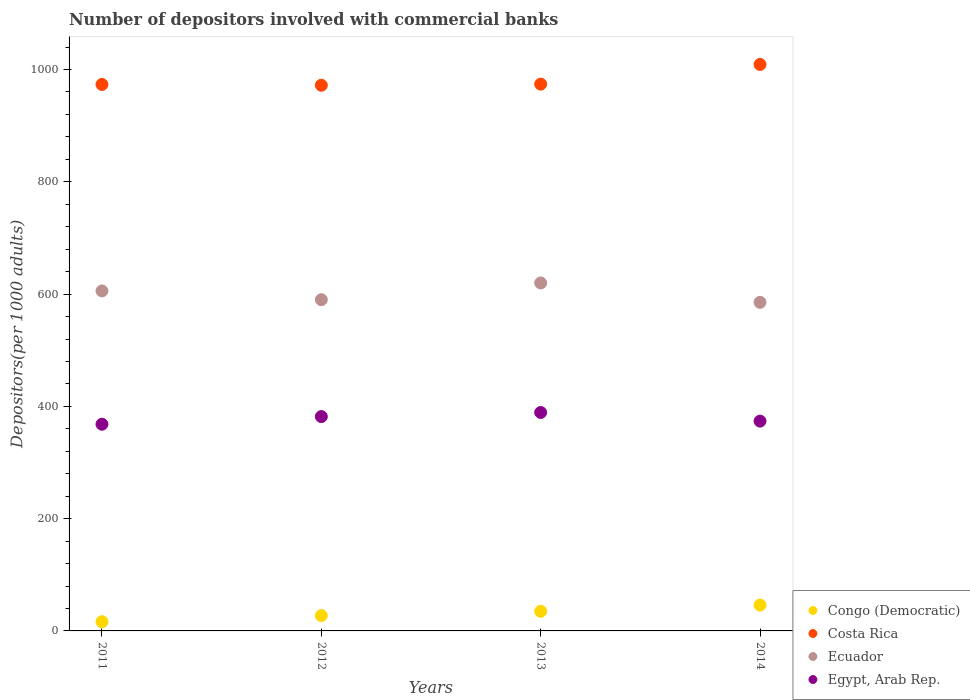Is the number of dotlines equal to the number of legend labels?
Offer a very short reply. Yes. What is the number of depositors involved with commercial banks in Costa Rica in 2012?
Make the answer very short. 972. Across all years, what is the maximum number of depositors involved with commercial banks in Congo (Democratic)?
Offer a terse response. 46.03. Across all years, what is the minimum number of depositors involved with commercial banks in Costa Rica?
Keep it short and to the point. 972. In which year was the number of depositors involved with commercial banks in Congo (Democratic) maximum?
Keep it short and to the point. 2014. What is the total number of depositors involved with commercial banks in Congo (Democratic) in the graph?
Your answer should be very brief. 124.75. What is the difference between the number of depositors involved with commercial banks in Congo (Democratic) in 2012 and that in 2013?
Provide a succinct answer. -7.59. What is the difference between the number of depositors involved with commercial banks in Costa Rica in 2011 and the number of depositors involved with commercial banks in Congo (Democratic) in 2012?
Offer a very short reply. 946.05. What is the average number of depositors involved with commercial banks in Congo (Democratic) per year?
Make the answer very short. 31.19. In the year 2013, what is the difference between the number of depositors involved with commercial banks in Congo (Democratic) and number of depositors involved with commercial banks in Egypt, Arab Rep.?
Provide a short and direct response. -354.15. In how many years, is the number of depositors involved with commercial banks in Egypt, Arab Rep. greater than 960?
Your response must be concise. 0. What is the ratio of the number of depositors involved with commercial banks in Congo (Democratic) in 2012 to that in 2014?
Provide a short and direct response. 0.59. Is the number of depositors involved with commercial banks in Ecuador in 2013 less than that in 2014?
Provide a short and direct response. No. Is the difference between the number of depositors involved with commercial banks in Congo (Democratic) in 2013 and 2014 greater than the difference between the number of depositors involved with commercial banks in Egypt, Arab Rep. in 2013 and 2014?
Your response must be concise. No. What is the difference between the highest and the second highest number of depositors involved with commercial banks in Congo (Democratic)?
Your answer should be very brief. 11.08. What is the difference between the highest and the lowest number of depositors involved with commercial banks in Ecuador?
Offer a very short reply. 34.52. Is the sum of the number of depositors involved with commercial banks in Egypt, Arab Rep. in 2013 and 2014 greater than the maximum number of depositors involved with commercial banks in Congo (Democratic) across all years?
Your answer should be very brief. Yes. Is it the case that in every year, the sum of the number of depositors involved with commercial banks in Ecuador and number of depositors involved with commercial banks in Congo (Democratic)  is greater than the number of depositors involved with commercial banks in Costa Rica?
Ensure brevity in your answer.  No. Is the number of depositors involved with commercial banks in Congo (Democratic) strictly greater than the number of depositors involved with commercial banks in Costa Rica over the years?
Provide a succinct answer. No. How many years are there in the graph?
Make the answer very short. 4. Are the values on the major ticks of Y-axis written in scientific E-notation?
Offer a terse response. No. Does the graph contain any zero values?
Your response must be concise. No. What is the title of the graph?
Your answer should be compact. Number of depositors involved with commercial banks. Does "Cameroon" appear as one of the legend labels in the graph?
Keep it short and to the point. No. What is the label or title of the X-axis?
Make the answer very short. Years. What is the label or title of the Y-axis?
Ensure brevity in your answer.  Depositors(per 1000 adults). What is the Depositors(per 1000 adults) in Congo (Democratic) in 2011?
Your answer should be very brief. 16.41. What is the Depositors(per 1000 adults) of Costa Rica in 2011?
Provide a succinct answer. 973.42. What is the Depositors(per 1000 adults) of Ecuador in 2011?
Your answer should be very brief. 605.63. What is the Depositors(per 1000 adults) in Egypt, Arab Rep. in 2011?
Keep it short and to the point. 368.19. What is the Depositors(per 1000 adults) in Congo (Democratic) in 2012?
Your answer should be compact. 27.36. What is the Depositors(per 1000 adults) of Costa Rica in 2012?
Your response must be concise. 972. What is the Depositors(per 1000 adults) in Ecuador in 2012?
Provide a succinct answer. 590.02. What is the Depositors(per 1000 adults) of Egypt, Arab Rep. in 2012?
Offer a very short reply. 381.83. What is the Depositors(per 1000 adults) of Congo (Democratic) in 2013?
Provide a succinct answer. 34.95. What is the Depositors(per 1000 adults) of Costa Rica in 2013?
Make the answer very short. 974. What is the Depositors(per 1000 adults) of Ecuador in 2013?
Your answer should be very brief. 619.83. What is the Depositors(per 1000 adults) of Egypt, Arab Rep. in 2013?
Your response must be concise. 389.11. What is the Depositors(per 1000 adults) in Congo (Democratic) in 2014?
Offer a terse response. 46.03. What is the Depositors(per 1000 adults) in Costa Rica in 2014?
Provide a short and direct response. 1009.08. What is the Depositors(per 1000 adults) of Ecuador in 2014?
Offer a terse response. 585.31. What is the Depositors(per 1000 adults) in Egypt, Arab Rep. in 2014?
Your answer should be very brief. 373.74. Across all years, what is the maximum Depositors(per 1000 adults) in Congo (Democratic)?
Offer a terse response. 46.03. Across all years, what is the maximum Depositors(per 1000 adults) of Costa Rica?
Your response must be concise. 1009.08. Across all years, what is the maximum Depositors(per 1000 adults) of Ecuador?
Provide a succinct answer. 619.83. Across all years, what is the maximum Depositors(per 1000 adults) of Egypt, Arab Rep.?
Your response must be concise. 389.11. Across all years, what is the minimum Depositors(per 1000 adults) in Congo (Democratic)?
Give a very brief answer. 16.41. Across all years, what is the minimum Depositors(per 1000 adults) of Costa Rica?
Provide a short and direct response. 972. Across all years, what is the minimum Depositors(per 1000 adults) of Ecuador?
Your response must be concise. 585.31. Across all years, what is the minimum Depositors(per 1000 adults) of Egypt, Arab Rep.?
Your response must be concise. 368.19. What is the total Depositors(per 1000 adults) in Congo (Democratic) in the graph?
Your response must be concise. 124.75. What is the total Depositors(per 1000 adults) of Costa Rica in the graph?
Provide a short and direct response. 3928.5. What is the total Depositors(per 1000 adults) in Ecuador in the graph?
Provide a succinct answer. 2400.79. What is the total Depositors(per 1000 adults) of Egypt, Arab Rep. in the graph?
Your answer should be very brief. 1512.86. What is the difference between the Depositors(per 1000 adults) in Congo (Democratic) in 2011 and that in 2012?
Make the answer very short. -10.96. What is the difference between the Depositors(per 1000 adults) of Costa Rica in 2011 and that in 2012?
Keep it short and to the point. 1.42. What is the difference between the Depositors(per 1000 adults) in Ecuador in 2011 and that in 2012?
Your answer should be compact. 15.61. What is the difference between the Depositors(per 1000 adults) in Egypt, Arab Rep. in 2011 and that in 2012?
Make the answer very short. -13.63. What is the difference between the Depositors(per 1000 adults) of Congo (Democratic) in 2011 and that in 2013?
Your response must be concise. -18.55. What is the difference between the Depositors(per 1000 adults) in Costa Rica in 2011 and that in 2013?
Provide a short and direct response. -0.59. What is the difference between the Depositors(per 1000 adults) in Ecuador in 2011 and that in 2013?
Ensure brevity in your answer.  -14.2. What is the difference between the Depositors(per 1000 adults) in Egypt, Arab Rep. in 2011 and that in 2013?
Your answer should be compact. -20.91. What is the difference between the Depositors(per 1000 adults) of Congo (Democratic) in 2011 and that in 2014?
Your answer should be very brief. -29.62. What is the difference between the Depositors(per 1000 adults) in Costa Rica in 2011 and that in 2014?
Ensure brevity in your answer.  -35.66. What is the difference between the Depositors(per 1000 adults) in Ecuador in 2011 and that in 2014?
Your response must be concise. 20.33. What is the difference between the Depositors(per 1000 adults) of Egypt, Arab Rep. in 2011 and that in 2014?
Ensure brevity in your answer.  -5.54. What is the difference between the Depositors(per 1000 adults) in Congo (Democratic) in 2012 and that in 2013?
Keep it short and to the point. -7.59. What is the difference between the Depositors(per 1000 adults) in Costa Rica in 2012 and that in 2013?
Provide a short and direct response. -2. What is the difference between the Depositors(per 1000 adults) of Ecuador in 2012 and that in 2013?
Your response must be concise. -29.81. What is the difference between the Depositors(per 1000 adults) in Egypt, Arab Rep. in 2012 and that in 2013?
Your answer should be very brief. -7.28. What is the difference between the Depositors(per 1000 adults) in Congo (Democratic) in 2012 and that in 2014?
Provide a short and direct response. -18.67. What is the difference between the Depositors(per 1000 adults) in Costa Rica in 2012 and that in 2014?
Ensure brevity in your answer.  -37.08. What is the difference between the Depositors(per 1000 adults) of Ecuador in 2012 and that in 2014?
Your answer should be very brief. 4.71. What is the difference between the Depositors(per 1000 adults) of Egypt, Arab Rep. in 2012 and that in 2014?
Provide a short and direct response. 8.09. What is the difference between the Depositors(per 1000 adults) of Congo (Democratic) in 2013 and that in 2014?
Provide a short and direct response. -11.08. What is the difference between the Depositors(per 1000 adults) in Costa Rica in 2013 and that in 2014?
Make the answer very short. -35.08. What is the difference between the Depositors(per 1000 adults) of Ecuador in 2013 and that in 2014?
Offer a terse response. 34.52. What is the difference between the Depositors(per 1000 adults) of Egypt, Arab Rep. in 2013 and that in 2014?
Keep it short and to the point. 15.37. What is the difference between the Depositors(per 1000 adults) in Congo (Democratic) in 2011 and the Depositors(per 1000 adults) in Costa Rica in 2012?
Give a very brief answer. -955.59. What is the difference between the Depositors(per 1000 adults) in Congo (Democratic) in 2011 and the Depositors(per 1000 adults) in Ecuador in 2012?
Ensure brevity in your answer.  -573.61. What is the difference between the Depositors(per 1000 adults) in Congo (Democratic) in 2011 and the Depositors(per 1000 adults) in Egypt, Arab Rep. in 2012?
Make the answer very short. -365.42. What is the difference between the Depositors(per 1000 adults) in Costa Rica in 2011 and the Depositors(per 1000 adults) in Ecuador in 2012?
Offer a terse response. 383.4. What is the difference between the Depositors(per 1000 adults) of Costa Rica in 2011 and the Depositors(per 1000 adults) of Egypt, Arab Rep. in 2012?
Offer a terse response. 591.59. What is the difference between the Depositors(per 1000 adults) of Ecuador in 2011 and the Depositors(per 1000 adults) of Egypt, Arab Rep. in 2012?
Your response must be concise. 223.81. What is the difference between the Depositors(per 1000 adults) in Congo (Democratic) in 2011 and the Depositors(per 1000 adults) in Costa Rica in 2013?
Your response must be concise. -957.6. What is the difference between the Depositors(per 1000 adults) in Congo (Democratic) in 2011 and the Depositors(per 1000 adults) in Ecuador in 2013?
Keep it short and to the point. -603.42. What is the difference between the Depositors(per 1000 adults) of Congo (Democratic) in 2011 and the Depositors(per 1000 adults) of Egypt, Arab Rep. in 2013?
Give a very brief answer. -372.7. What is the difference between the Depositors(per 1000 adults) in Costa Rica in 2011 and the Depositors(per 1000 adults) in Ecuador in 2013?
Offer a very short reply. 353.59. What is the difference between the Depositors(per 1000 adults) in Costa Rica in 2011 and the Depositors(per 1000 adults) in Egypt, Arab Rep. in 2013?
Offer a terse response. 584.31. What is the difference between the Depositors(per 1000 adults) of Ecuador in 2011 and the Depositors(per 1000 adults) of Egypt, Arab Rep. in 2013?
Provide a short and direct response. 216.53. What is the difference between the Depositors(per 1000 adults) in Congo (Democratic) in 2011 and the Depositors(per 1000 adults) in Costa Rica in 2014?
Your answer should be very brief. -992.67. What is the difference between the Depositors(per 1000 adults) of Congo (Democratic) in 2011 and the Depositors(per 1000 adults) of Ecuador in 2014?
Your answer should be compact. -568.9. What is the difference between the Depositors(per 1000 adults) in Congo (Democratic) in 2011 and the Depositors(per 1000 adults) in Egypt, Arab Rep. in 2014?
Make the answer very short. -357.33. What is the difference between the Depositors(per 1000 adults) in Costa Rica in 2011 and the Depositors(per 1000 adults) in Ecuador in 2014?
Make the answer very short. 388.11. What is the difference between the Depositors(per 1000 adults) of Costa Rica in 2011 and the Depositors(per 1000 adults) of Egypt, Arab Rep. in 2014?
Make the answer very short. 599.68. What is the difference between the Depositors(per 1000 adults) in Ecuador in 2011 and the Depositors(per 1000 adults) in Egypt, Arab Rep. in 2014?
Offer a terse response. 231.9. What is the difference between the Depositors(per 1000 adults) in Congo (Democratic) in 2012 and the Depositors(per 1000 adults) in Costa Rica in 2013?
Your answer should be very brief. -946.64. What is the difference between the Depositors(per 1000 adults) in Congo (Democratic) in 2012 and the Depositors(per 1000 adults) in Ecuador in 2013?
Offer a very short reply. -592.47. What is the difference between the Depositors(per 1000 adults) of Congo (Democratic) in 2012 and the Depositors(per 1000 adults) of Egypt, Arab Rep. in 2013?
Provide a short and direct response. -361.74. What is the difference between the Depositors(per 1000 adults) of Costa Rica in 2012 and the Depositors(per 1000 adults) of Ecuador in 2013?
Your answer should be very brief. 352.17. What is the difference between the Depositors(per 1000 adults) in Costa Rica in 2012 and the Depositors(per 1000 adults) in Egypt, Arab Rep. in 2013?
Provide a short and direct response. 582.9. What is the difference between the Depositors(per 1000 adults) in Ecuador in 2012 and the Depositors(per 1000 adults) in Egypt, Arab Rep. in 2013?
Your answer should be very brief. 200.92. What is the difference between the Depositors(per 1000 adults) of Congo (Democratic) in 2012 and the Depositors(per 1000 adults) of Costa Rica in 2014?
Provide a succinct answer. -981.72. What is the difference between the Depositors(per 1000 adults) of Congo (Democratic) in 2012 and the Depositors(per 1000 adults) of Ecuador in 2014?
Your answer should be compact. -557.95. What is the difference between the Depositors(per 1000 adults) in Congo (Democratic) in 2012 and the Depositors(per 1000 adults) in Egypt, Arab Rep. in 2014?
Your answer should be very brief. -346.37. What is the difference between the Depositors(per 1000 adults) of Costa Rica in 2012 and the Depositors(per 1000 adults) of Ecuador in 2014?
Your response must be concise. 386.69. What is the difference between the Depositors(per 1000 adults) in Costa Rica in 2012 and the Depositors(per 1000 adults) in Egypt, Arab Rep. in 2014?
Your response must be concise. 598.26. What is the difference between the Depositors(per 1000 adults) of Ecuador in 2012 and the Depositors(per 1000 adults) of Egypt, Arab Rep. in 2014?
Ensure brevity in your answer.  216.28. What is the difference between the Depositors(per 1000 adults) in Congo (Democratic) in 2013 and the Depositors(per 1000 adults) in Costa Rica in 2014?
Your answer should be compact. -974.13. What is the difference between the Depositors(per 1000 adults) in Congo (Democratic) in 2013 and the Depositors(per 1000 adults) in Ecuador in 2014?
Keep it short and to the point. -550.36. What is the difference between the Depositors(per 1000 adults) in Congo (Democratic) in 2013 and the Depositors(per 1000 adults) in Egypt, Arab Rep. in 2014?
Make the answer very short. -338.79. What is the difference between the Depositors(per 1000 adults) of Costa Rica in 2013 and the Depositors(per 1000 adults) of Ecuador in 2014?
Your answer should be very brief. 388.69. What is the difference between the Depositors(per 1000 adults) in Costa Rica in 2013 and the Depositors(per 1000 adults) in Egypt, Arab Rep. in 2014?
Your answer should be compact. 600.27. What is the difference between the Depositors(per 1000 adults) of Ecuador in 2013 and the Depositors(per 1000 adults) of Egypt, Arab Rep. in 2014?
Offer a terse response. 246.09. What is the average Depositors(per 1000 adults) of Congo (Democratic) per year?
Provide a short and direct response. 31.19. What is the average Depositors(per 1000 adults) of Costa Rica per year?
Give a very brief answer. 982.12. What is the average Depositors(per 1000 adults) in Ecuador per year?
Your answer should be compact. 600.2. What is the average Depositors(per 1000 adults) in Egypt, Arab Rep. per year?
Offer a very short reply. 378.22. In the year 2011, what is the difference between the Depositors(per 1000 adults) of Congo (Democratic) and Depositors(per 1000 adults) of Costa Rica?
Keep it short and to the point. -957.01. In the year 2011, what is the difference between the Depositors(per 1000 adults) in Congo (Democratic) and Depositors(per 1000 adults) in Ecuador?
Offer a very short reply. -589.23. In the year 2011, what is the difference between the Depositors(per 1000 adults) in Congo (Democratic) and Depositors(per 1000 adults) in Egypt, Arab Rep.?
Provide a succinct answer. -351.79. In the year 2011, what is the difference between the Depositors(per 1000 adults) of Costa Rica and Depositors(per 1000 adults) of Ecuador?
Keep it short and to the point. 367.78. In the year 2011, what is the difference between the Depositors(per 1000 adults) of Costa Rica and Depositors(per 1000 adults) of Egypt, Arab Rep.?
Your answer should be compact. 605.22. In the year 2011, what is the difference between the Depositors(per 1000 adults) of Ecuador and Depositors(per 1000 adults) of Egypt, Arab Rep.?
Your answer should be compact. 237.44. In the year 2012, what is the difference between the Depositors(per 1000 adults) in Congo (Democratic) and Depositors(per 1000 adults) in Costa Rica?
Your answer should be very brief. -944.64. In the year 2012, what is the difference between the Depositors(per 1000 adults) in Congo (Democratic) and Depositors(per 1000 adults) in Ecuador?
Offer a very short reply. -562.66. In the year 2012, what is the difference between the Depositors(per 1000 adults) of Congo (Democratic) and Depositors(per 1000 adults) of Egypt, Arab Rep.?
Make the answer very short. -354.46. In the year 2012, what is the difference between the Depositors(per 1000 adults) in Costa Rica and Depositors(per 1000 adults) in Ecuador?
Your answer should be compact. 381.98. In the year 2012, what is the difference between the Depositors(per 1000 adults) of Costa Rica and Depositors(per 1000 adults) of Egypt, Arab Rep.?
Make the answer very short. 590.17. In the year 2012, what is the difference between the Depositors(per 1000 adults) in Ecuador and Depositors(per 1000 adults) in Egypt, Arab Rep.?
Your response must be concise. 208.19. In the year 2013, what is the difference between the Depositors(per 1000 adults) in Congo (Democratic) and Depositors(per 1000 adults) in Costa Rica?
Give a very brief answer. -939.05. In the year 2013, what is the difference between the Depositors(per 1000 adults) of Congo (Democratic) and Depositors(per 1000 adults) of Ecuador?
Your answer should be very brief. -584.88. In the year 2013, what is the difference between the Depositors(per 1000 adults) of Congo (Democratic) and Depositors(per 1000 adults) of Egypt, Arab Rep.?
Offer a very short reply. -354.15. In the year 2013, what is the difference between the Depositors(per 1000 adults) of Costa Rica and Depositors(per 1000 adults) of Ecuador?
Make the answer very short. 354.17. In the year 2013, what is the difference between the Depositors(per 1000 adults) in Costa Rica and Depositors(per 1000 adults) in Egypt, Arab Rep.?
Offer a very short reply. 584.9. In the year 2013, what is the difference between the Depositors(per 1000 adults) of Ecuador and Depositors(per 1000 adults) of Egypt, Arab Rep.?
Provide a succinct answer. 230.72. In the year 2014, what is the difference between the Depositors(per 1000 adults) in Congo (Democratic) and Depositors(per 1000 adults) in Costa Rica?
Your answer should be compact. -963.05. In the year 2014, what is the difference between the Depositors(per 1000 adults) of Congo (Democratic) and Depositors(per 1000 adults) of Ecuador?
Keep it short and to the point. -539.28. In the year 2014, what is the difference between the Depositors(per 1000 adults) of Congo (Democratic) and Depositors(per 1000 adults) of Egypt, Arab Rep.?
Offer a terse response. -327.71. In the year 2014, what is the difference between the Depositors(per 1000 adults) in Costa Rica and Depositors(per 1000 adults) in Ecuador?
Offer a very short reply. 423.77. In the year 2014, what is the difference between the Depositors(per 1000 adults) in Costa Rica and Depositors(per 1000 adults) in Egypt, Arab Rep.?
Offer a terse response. 635.34. In the year 2014, what is the difference between the Depositors(per 1000 adults) in Ecuador and Depositors(per 1000 adults) in Egypt, Arab Rep.?
Provide a succinct answer. 211.57. What is the ratio of the Depositors(per 1000 adults) in Congo (Democratic) in 2011 to that in 2012?
Ensure brevity in your answer.  0.6. What is the ratio of the Depositors(per 1000 adults) in Costa Rica in 2011 to that in 2012?
Provide a succinct answer. 1. What is the ratio of the Depositors(per 1000 adults) in Ecuador in 2011 to that in 2012?
Give a very brief answer. 1.03. What is the ratio of the Depositors(per 1000 adults) in Congo (Democratic) in 2011 to that in 2013?
Your answer should be compact. 0.47. What is the ratio of the Depositors(per 1000 adults) of Costa Rica in 2011 to that in 2013?
Keep it short and to the point. 1. What is the ratio of the Depositors(per 1000 adults) of Ecuador in 2011 to that in 2013?
Keep it short and to the point. 0.98. What is the ratio of the Depositors(per 1000 adults) of Egypt, Arab Rep. in 2011 to that in 2013?
Provide a short and direct response. 0.95. What is the ratio of the Depositors(per 1000 adults) of Congo (Democratic) in 2011 to that in 2014?
Ensure brevity in your answer.  0.36. What is the ratio of the Depositors(per 1000 adults) of Costa Rica in 2011 to that in 2014?
Your answer should be compact. 0.96. What is the ratio of the Depositors(per 1000 adults) of Ecuador in 2011 to that in 2014?
Offer a very short reply. 1.03. What is the ratio of the Depositors(per 1000 adults) of Egypt, Arab Rep. in 2011 to that in 2014?
Provide a succinct answer. 0.99. What is the ratio of the Depositors(per 1000 adults) of Congo (Democratic) in 2012 to that in 2013?
Keep it short and to the point. 0.78. What is the ratio of the Depositors(per 1000 adults) of Costa Rica in 2012 to that in 2013?
Offer a very short reply. 1. What is the ratio of the Depositors(per 1000 adults) of Ecuador in 2012 to that in 2013?
Provide a short and direct response. 0.95. What is the ratio of the Depositors(per 1000 adults) of Egypt, Arab Rep. in 2012 to that in 2013?
Keep it short and to the point. 0.98. What is the ratio of the Depositors(per 1000 adults) in Congo (Democratic) in 2012 to that in 2014?
Provide a short and direct response. 0.59. What is the ratio of the Depositors(per 1000 adults) of Costa Rica in 2012 to that in 2014?
Provide a short and direct response. 0.96. What is the ratio of the Depositors(per 1000 adults) in Egypt, Arab Rep. in 2012 to that in 2014?
Provide a short and direct response. 1.02. What is the ratio of the Depositors(per 1000 adults) of Congo (Democratic) in 2013 to that in 2014?
Offer a terse response. 0.76. What is the ratio of the Depositors(per 1000 adults) in Costa Rica in 2013 to that in 2014?
Your response must be concise. 0.97. What is the ratio of the Depositors(per 1000 adults) in Ecuador in 2013 to that in 2014?
Your response must be concise. 1.06. What is the ratio of the Depositors(per 1000 adults) in Egypt, Arab Rep. in 2013 to that in 2014?
Ensure brevity in your answer.  1.04. What is the difference between the highest and the second highest Depositors(per 1000 adults) in Congo (Democratic)?
Offer a terse response. 11.08. What is the difference between the highest and the second highest Depositors(per 1000 adults) in Costa Rica?
Keep it short and to the point. 35.08. What is the difference between the highest and the second highest Depositors(per 1000 adults) of Ecuador?
Give a very brief answer. 14.2. What is the difference between the highest and the second highest Depositors(per 1000 adults) in Egypt, Arab Rep.?
Ensure brevity in your answer.  7.28. What is the difference between the highest and the lowest Depositors(per 1000 adults) of Congo (Democratic)?
Offer a terse response. 29.62. What is the difference between the highest and the lowest Depositors(per 1000 adults) in Costa Rica?
Offer a very short reply. 37.08. What is the difference between the highest and the lowest Depositors(per 1000 adults) of Ecuador?
Your answer should be compact. 34.52. What is the difference between the highest and the lowest Depositors(per 1000 adults) of Egypt, Arab Rep.?
Provide a short and direct response. 20.91. 